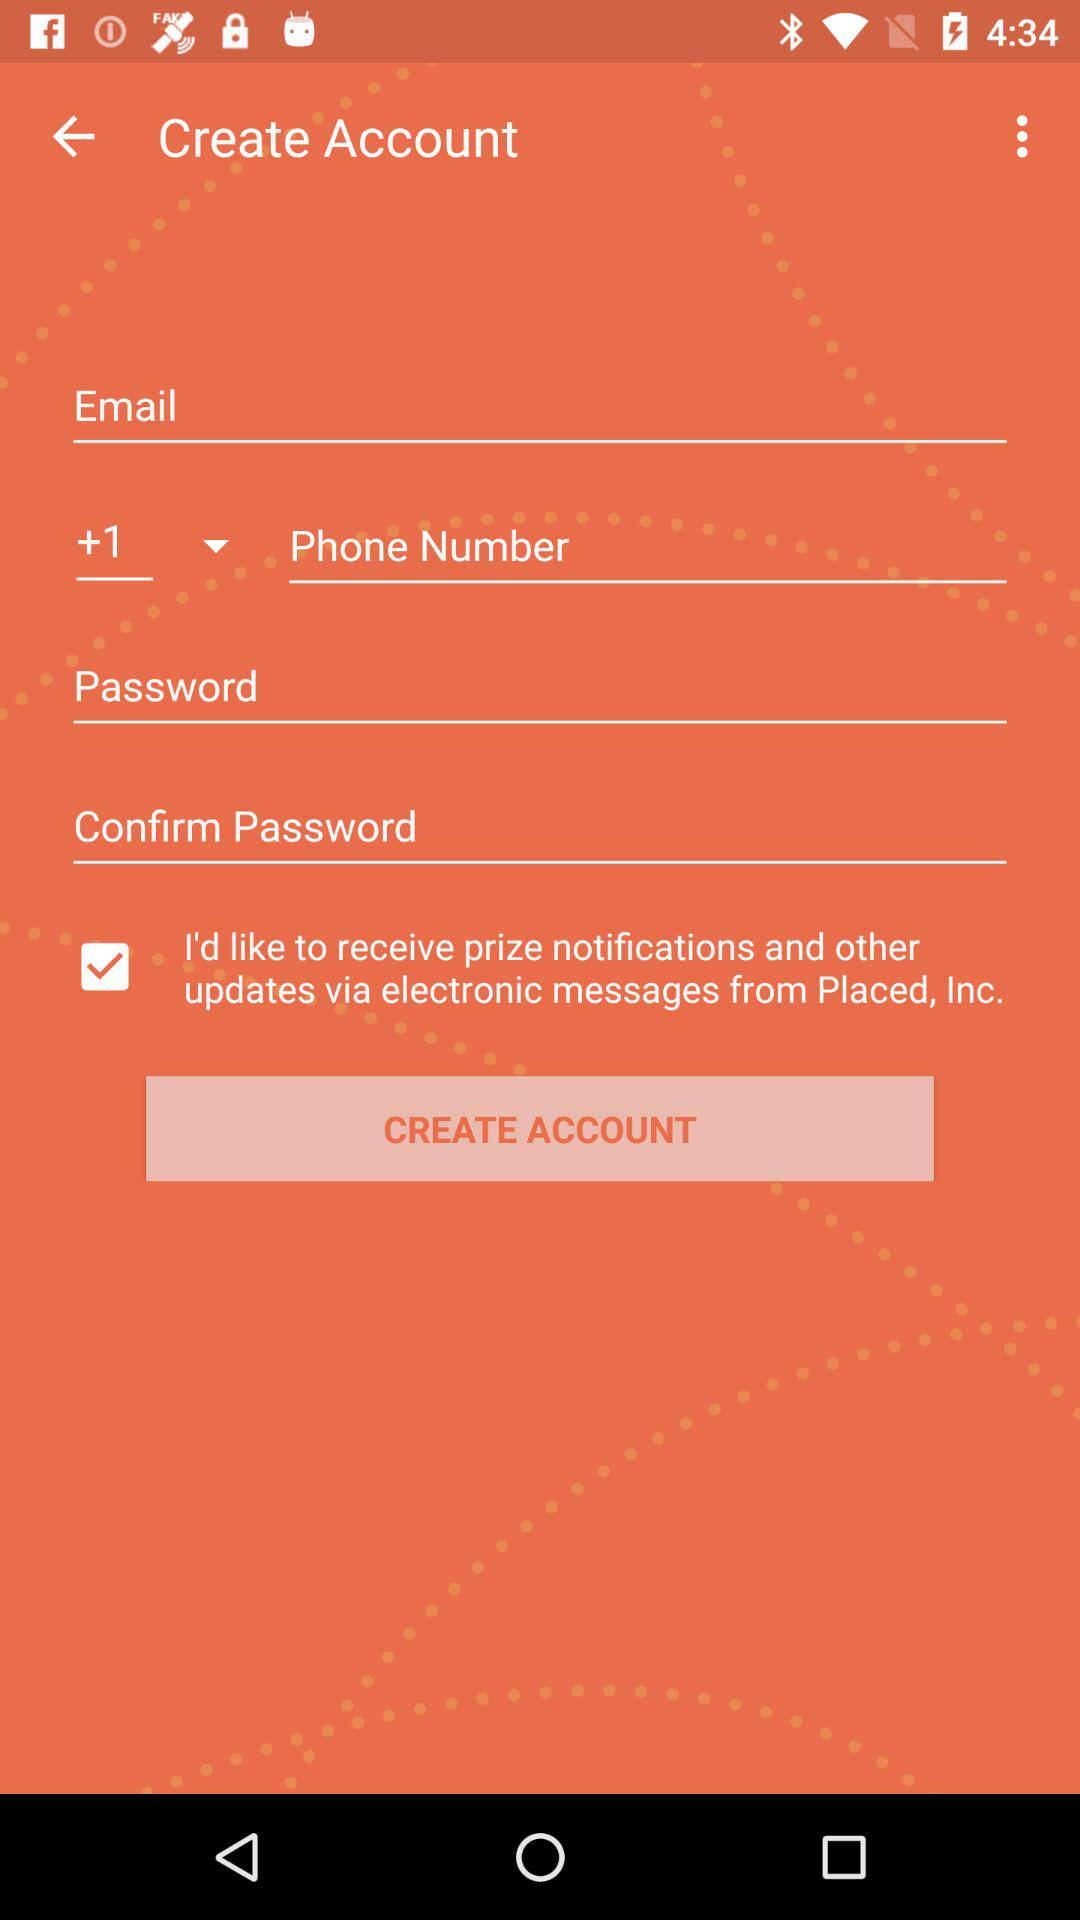What is the status of "I'd like to receive prize notifications and other updates via electronic messages from Placed, Inc."? The status is "on". 